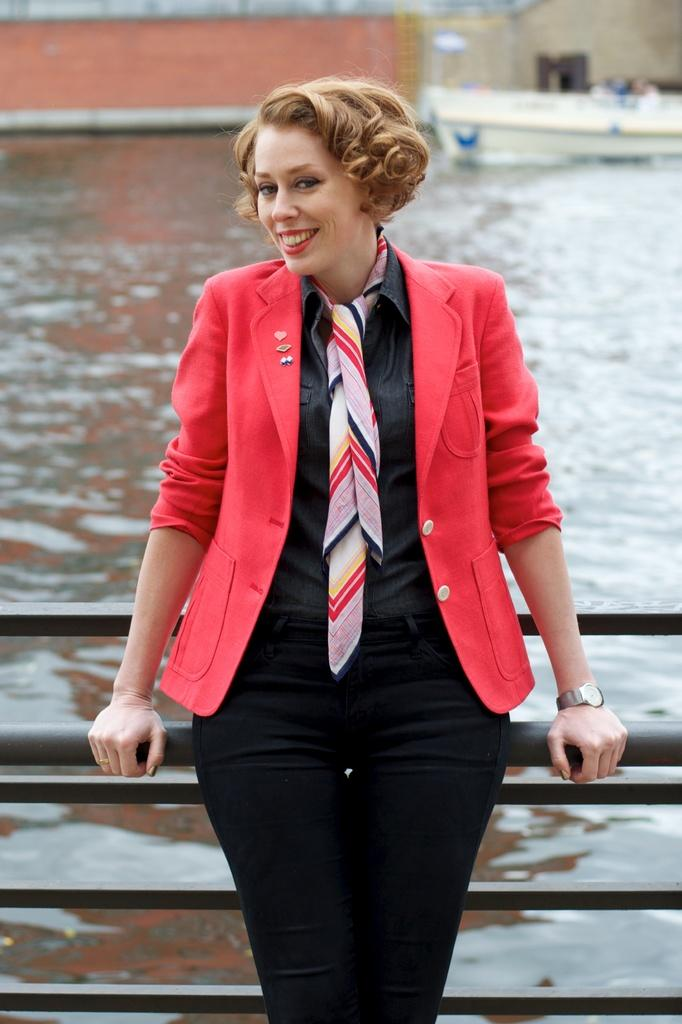Who is present in the image? There is a woman in the image. What is the woman doing in the image? The woman is watching and smiling in the image. What is the woman holding in the image? The woman is holding a rod in the image. Can you describe the background of the image? The background of the image is blurred. What else can be seen in the image besides the woman? There are rods, water, a boat, and walls visible in the image. What type of plastic is covering the lamp in the image? There is no lamp present in the image. What order is the woman following while holding the rod in the image? There is no order or specific action being followed by the woman while holding the rod in the image. 